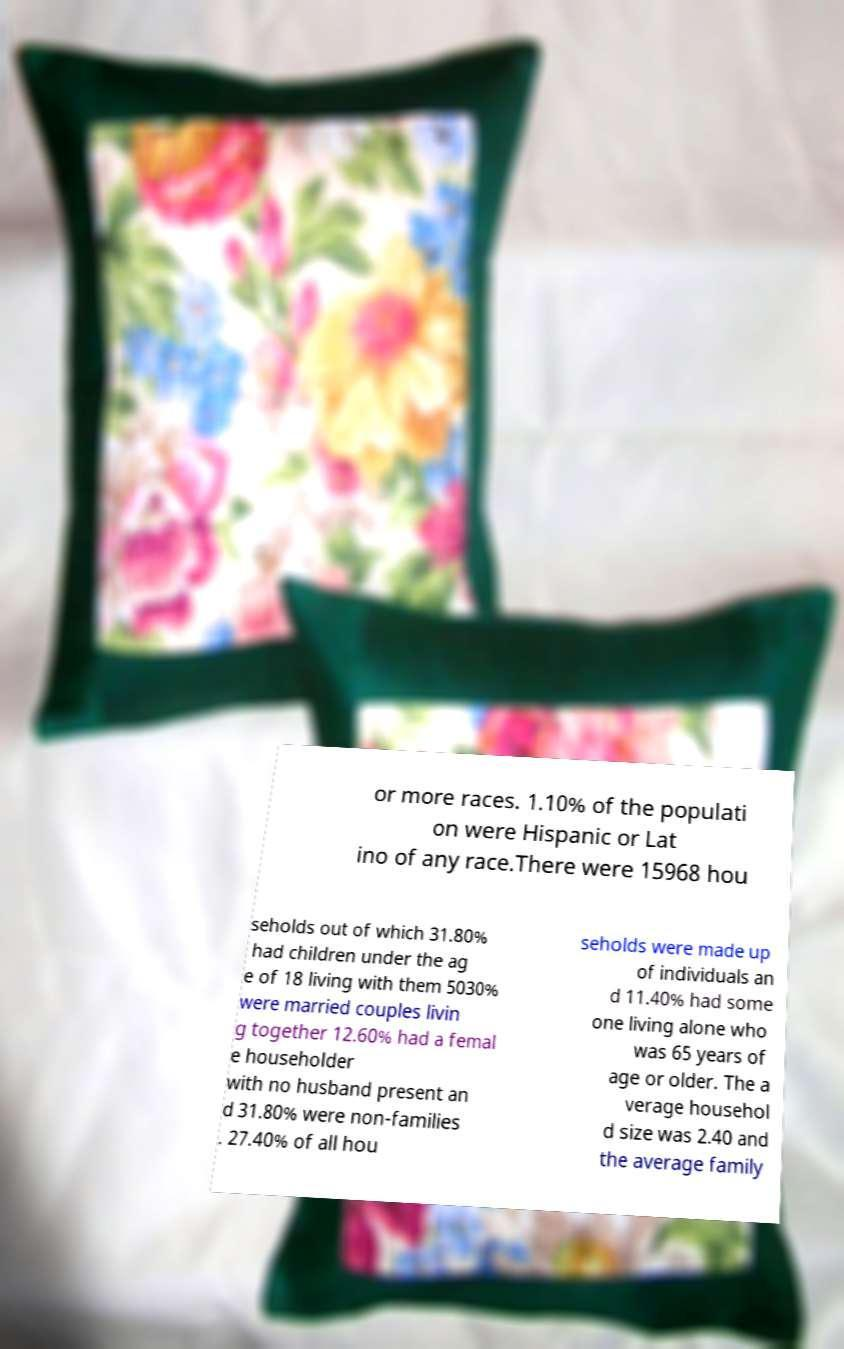For documentation purposes, I need the text within this image transcribed. Could you provide that? or more races. 1.10% of the populati on were Hispanic or Lat ino of any race.There were 15968 hou seholds out of which 31.80% had children under the ag e of 18 living with them 5030% were married couples livin g together 12.60% had a femal e householder with no husband present an d 31.80% were non-families . 27.40% of all hou seholds were made up of individuals an d 11.40% had some one living alone who was 65 years of age or older. The a verage househol d size was 2.40 and the average family 